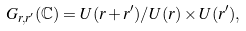<formula> <loc_0><loc_0><loc_500><loc_500>G _ { r , r ^ { \prime } } ( \mathbb { C } ) = U ( r + r ^ { \prime } ) / U ( r ) \times U ( r ^ { \prime } ) ,</formula> 